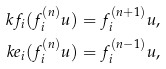<formula> <loc_0><loc_0><loc_500><loc_500>\ k f _ { i } ( f _ { i } ^ { ( n ) } u ) = f _ { i } ^ { ( n + 1 ) } u , \\ \ k e _ { i } ( f _ { i } ^ { ( n ) } u ) = f _ { i } ^ { ( n - 1 ) } u ,</formula> 